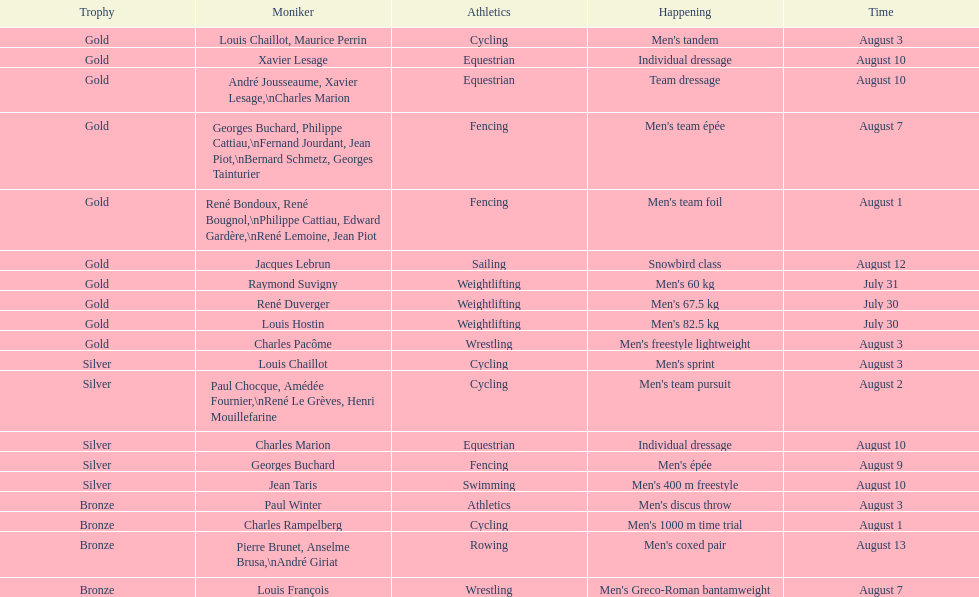Louis chaillot won a gold medal for cycling and a silver medal for what sport? Cycling. 